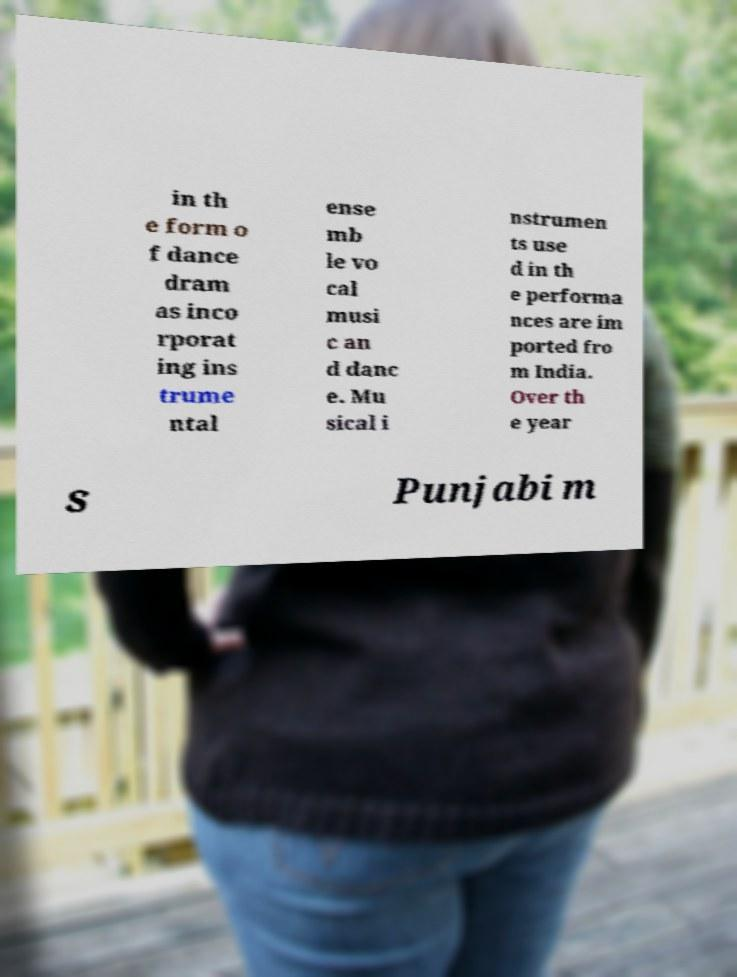Please identify and transcribe the text found in this image. in th e form o f dance dram as inco rporat ing ins trume ntal ense mb le vo cal musi c an d danc e. Mu sical i nstrumen ts use d in th e performa nces are im ported fro m India. Over th e year s Punjabi m 